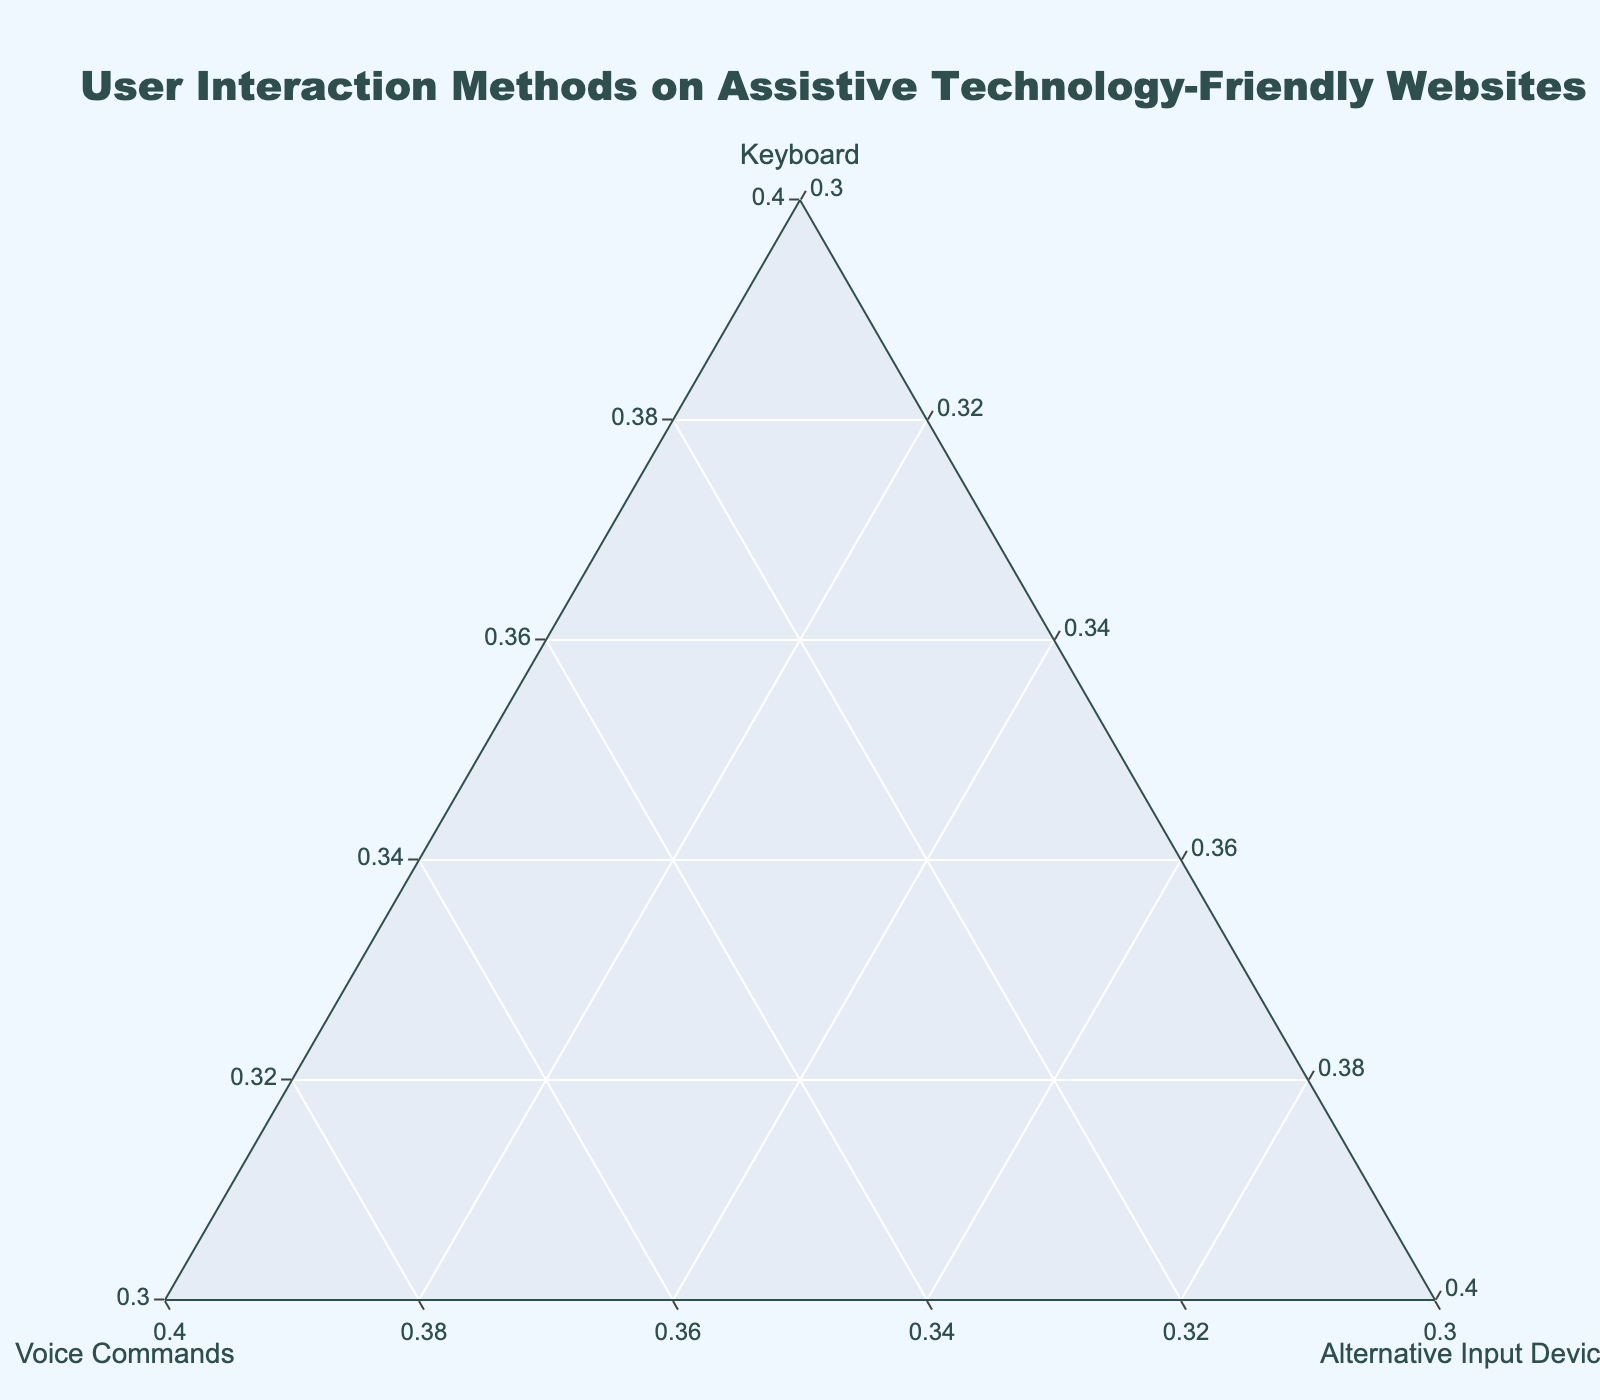what is the title of the figure? The title is typically shown at the top of the figure. Observing the rendered plot, we can see the title "User Interaction Methods on Assistive Technology-Friendly Websites."
Answer: User Interaction Methods on Assistive Technology-Friendly Websites How many websites have their primary user interaction method as 'Keyboard'? To determine this, count the number of data points closer to the 'Keyboard' axis. By inspecting, we see that there are 7 websites: Accessibility Hub, WebAIM Resources, A11Y Project, WCAG Guidelines Portal, Digital A11Y, Web Accessibility Initiative, and Screen Reader Friendly.
Answer: 7 Which websites have an equal percentage for 'Alternative Input Devices'? Look for websites positioned at the same point along the 'Alternative Input Devices' axis. All websites have 15% for 'Alternative Input Devices.' Therefore, all listed websites (13 total) share this characteristic.
Answer: All websites Which website uses 'Voice Commands' the most? Identify the data point furthest from the 'Keyboard' axis and closest to the 'Voice Commands' axis. The website "Voice Navigation Portal" is positioned closest to the 'Voice Commands' axis, indicating it uses Voice Commands the most at 45%.
Answer: Voice Navigation Portal What is the relative positioning of 'Screen Reader Friendly' compared to 'Voice Navigation Portal' in terms of 'Keyboard' usage? Compare the positions of these two on the 'Keyboard' axis. 'Screen Reader Friendly' is positioned closer to the 'Keyboard' apex, showing higher 'Keyboard' usage (75%) compared to 'Voice Navigation Portal' (40%).
Answer: Screen Reader Friendly shows higher keyboard usage What is the sum of the 'Voice Commands' percentages for ‘Inclusive Design Toolkit’ and ‘Assistive Tech Central’? Add together the given percentages from the figure. ‘Inclusive Design Toolkit’ has a 35% and 'Assistive Tech Central' has 40% for 'Voice Commands'. Therefore, 35 + 40 = 75.
Answer: 75% Are there more websites that primarily use 'Voice Commands' or 'Alternative Input Devices'? 'Alternative Input Devices' is consistently at 15% for all websites, indicating no primary usage. 'Voice Commands' maximum usage is observed only up to 45%. Hence, no website predominantly depends on 'Alternative Input Devices,' and fewer websites primarily use 'Voice Commands.'
Answer: More websites primarily use Voice Commands 